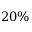Convert formula to latex. <formula><loc_0><loc_0><loc_500><loc_500>2 0 \%</formula> 